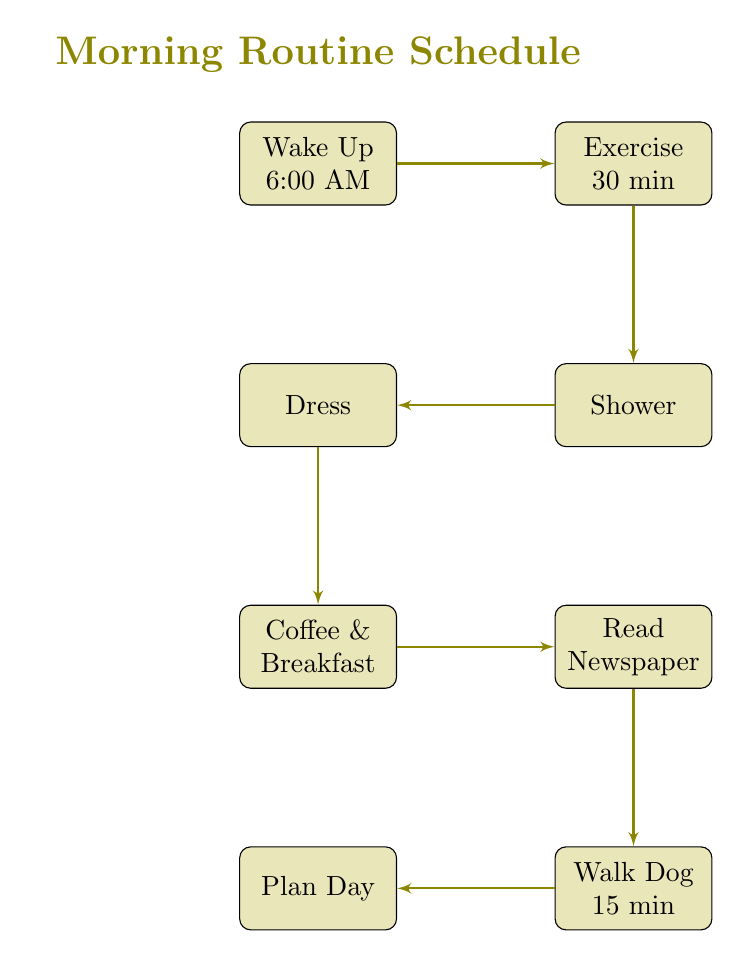What is the first step in the morning routine? According to the diagram, the first step, which is the starting node, is labeled "Wake Up". It is positioned at the top of the flowchart, indicating it is the initial action taken in the morning.
Answer: Wake Up How many total steps are in the morning routine? The diagram lists a total of eight distinct nodes representing each activity in the morning routine. Each of these activities contributes to the overall schedule from waking up to planning the day.
Answer: Eight What activity comes after "Exercise"? Following the "Exercise" block in the diagram, the next connected block is "Shower". The arrows indicate the flow from one activity to the next, clearly showing the sequence.
Answer: Shower Which activity involves reading? The "Read Newspaper" block in the diagram specifically refers to the action of reading, making it the only node detailing this activity in the morning routine.
Answer: Read Newspaper What is the duration of the "Walk Dog" activity? The "Walk Dog" node notes a time span of 15 minutes, which is indicated clearly within its description, representing how long this activity takes within the morning schedule.
Answer: 15 min How many connections are there leading from the "Coffee and Breakfast" node? The "Coffee and Breakfast" node has one outgoing connection leading directly to the "Read Newspaper" node. This indicates a direct flow from the breakfast activity to the next step.
Answer: One What is the last activity in the morning routine? The final node in the diagram is "Plan Day", which is positioned at the bottom of the flowchart, indicating it is the last step to be completed in the morning routine before moving on to daily tasks.
Answer: Plan Day 